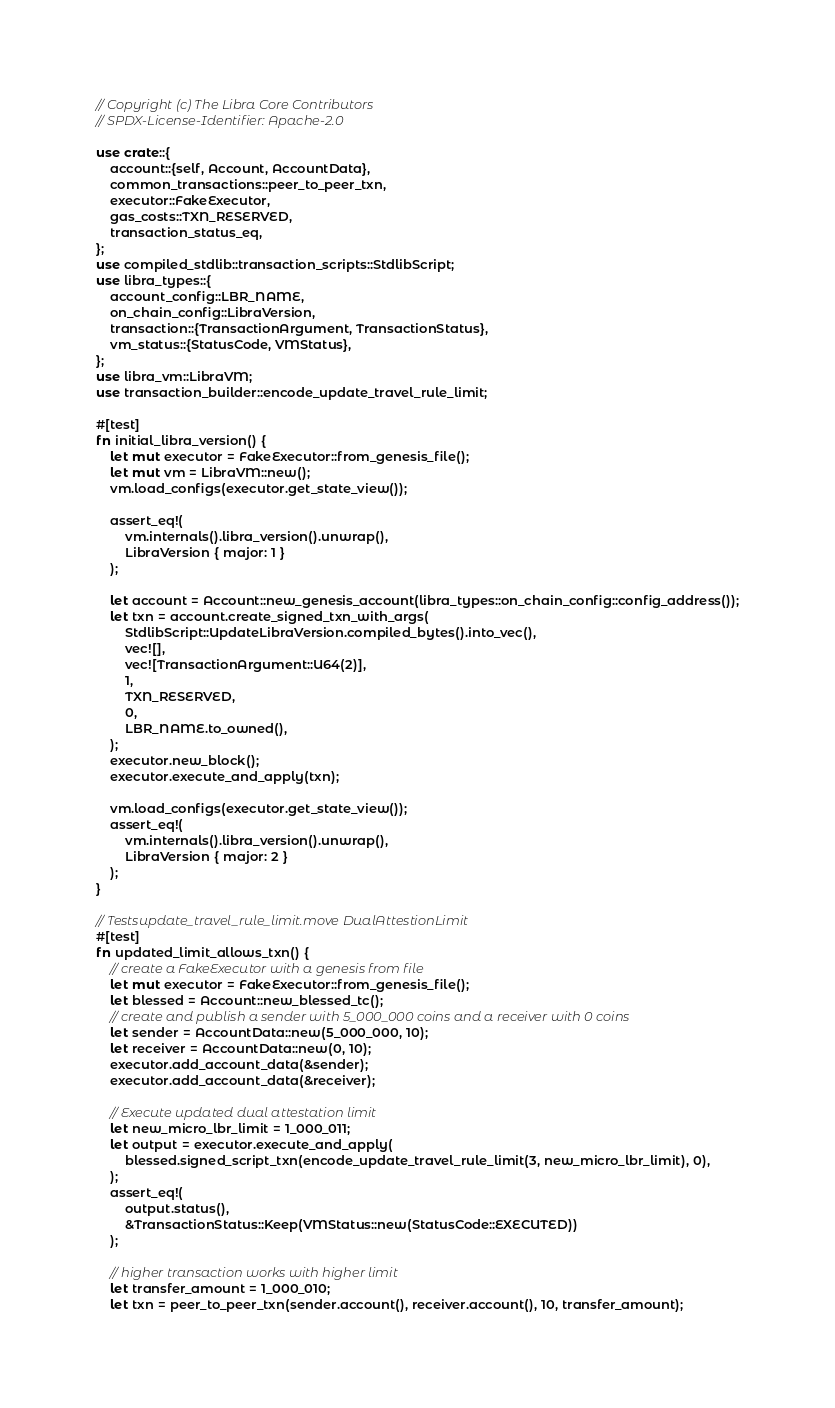Convert code to text. <code><loc_0><loc_0><loc_500><loc_500><_Rust_>// Copyright (c) The Libra Core Contributors
// SPDX-License-Identifier: Apache-2.0

use crate::{
    account::{self, Account, AccountData},
    common_transactions::peer_to_peer_txn,
    executor::FakeExecutor,
    gas_costs::TXN_RESERVED,
    transaction_status_eq,
};
use compiled_stdlib::transaction_scripts::StdlibScript;
use libra_types::{
    account_config::LBR_NAME,
    on_chain_config::LibraVersion,
    transaction::{TransactionArgument, TransactionStatus},
    vm_status::{StatusCode, VMStatus},
};
use libra_vm::LibraVM;
use transaction_builder::encode_update_travel_rule_limit;

#[test]
fn initial_libra_version() {
    let mut executor = FakeExecutor::from_genesis_file();
    let mut vm = LibraVM::new();
    vm.load_configs(executor.get_state_view());

    assert_eq!(
        vm.internals().libra_version().unwrap(),
        LibraVersion { major: 1 }
    );

    let account = Account::new_genesis_account(libra_types::on_chain_config::config_address());
    let txn = account.create_signed_txn_with_args(
        StdlibScript::UpdateLibraVersion.compiled_bytes().into_vec(),
        vec![],
        vec![TransactionArgument::U64(2)],
        1,
        TXN_RESERVED,
        0,
        LBR_NAME.to_owned(),
    );
    executor.new_block();
    executor.execute_and_apply(txn);

    vm.load_configs(executor.get_state_view());
    assert_eq!(
        vm.internals().libra_version().unwrap(),
        LibraVersion { major: 2 }
    );
}

// Testsupdate_travel_rule_limit.move DualAttestionLimit
#[test]
fn updated_limit_allows_txn() {
    // create a FakeExecutor with a genesis from file
    let mut executor = FakeExecutor::from_genesis_file();
    let blessed = Account::new_blessed_tc();
    // create and publish a sender with 5_000_000 coins and a receiver with 0 coins
    let sender = AccountData::new(5_000_000, 10);
    let receiver = AccountData::new(0, 10);
    executor.add_account_data(&sender);
    executor.add_account_data(&receiver);

    // Execute updated dual attestation limit
    let new_micro_lbr_limit = 1_000_011;
    let output = executor.execute_and_apply(
        blessed.signed_script_txn(encode_update_travel_rule_limit(3, new_micro_lbr_limit), 0),
    );
    assert_eq!(
        output.status(),
        &TransactionStatus::Keep(VMStatus::new(StatusCode::EXECUTED))
    );

    // higher transaction works with higher limit
    let transfer_amount = 1_000_010;
    let txn = peer_to_peer_txn(sender.account(), receiver.account(), 10, transfer_amount);</code> 